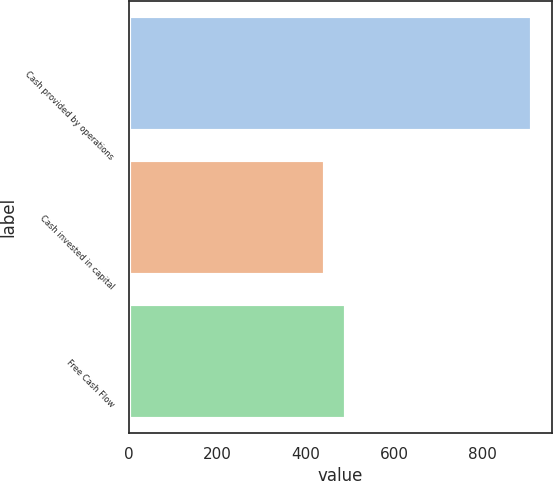Convert chart to OTSL. <chart><loc_0><loc_0><loc_500><loc_500><bar_chart><fcel>Cash provided by operations<fcel>Cash invested in capital<fcel>Free Cash Flow<nl><fcel>912<fcel>445<fcel>491.7<nl></chart> 